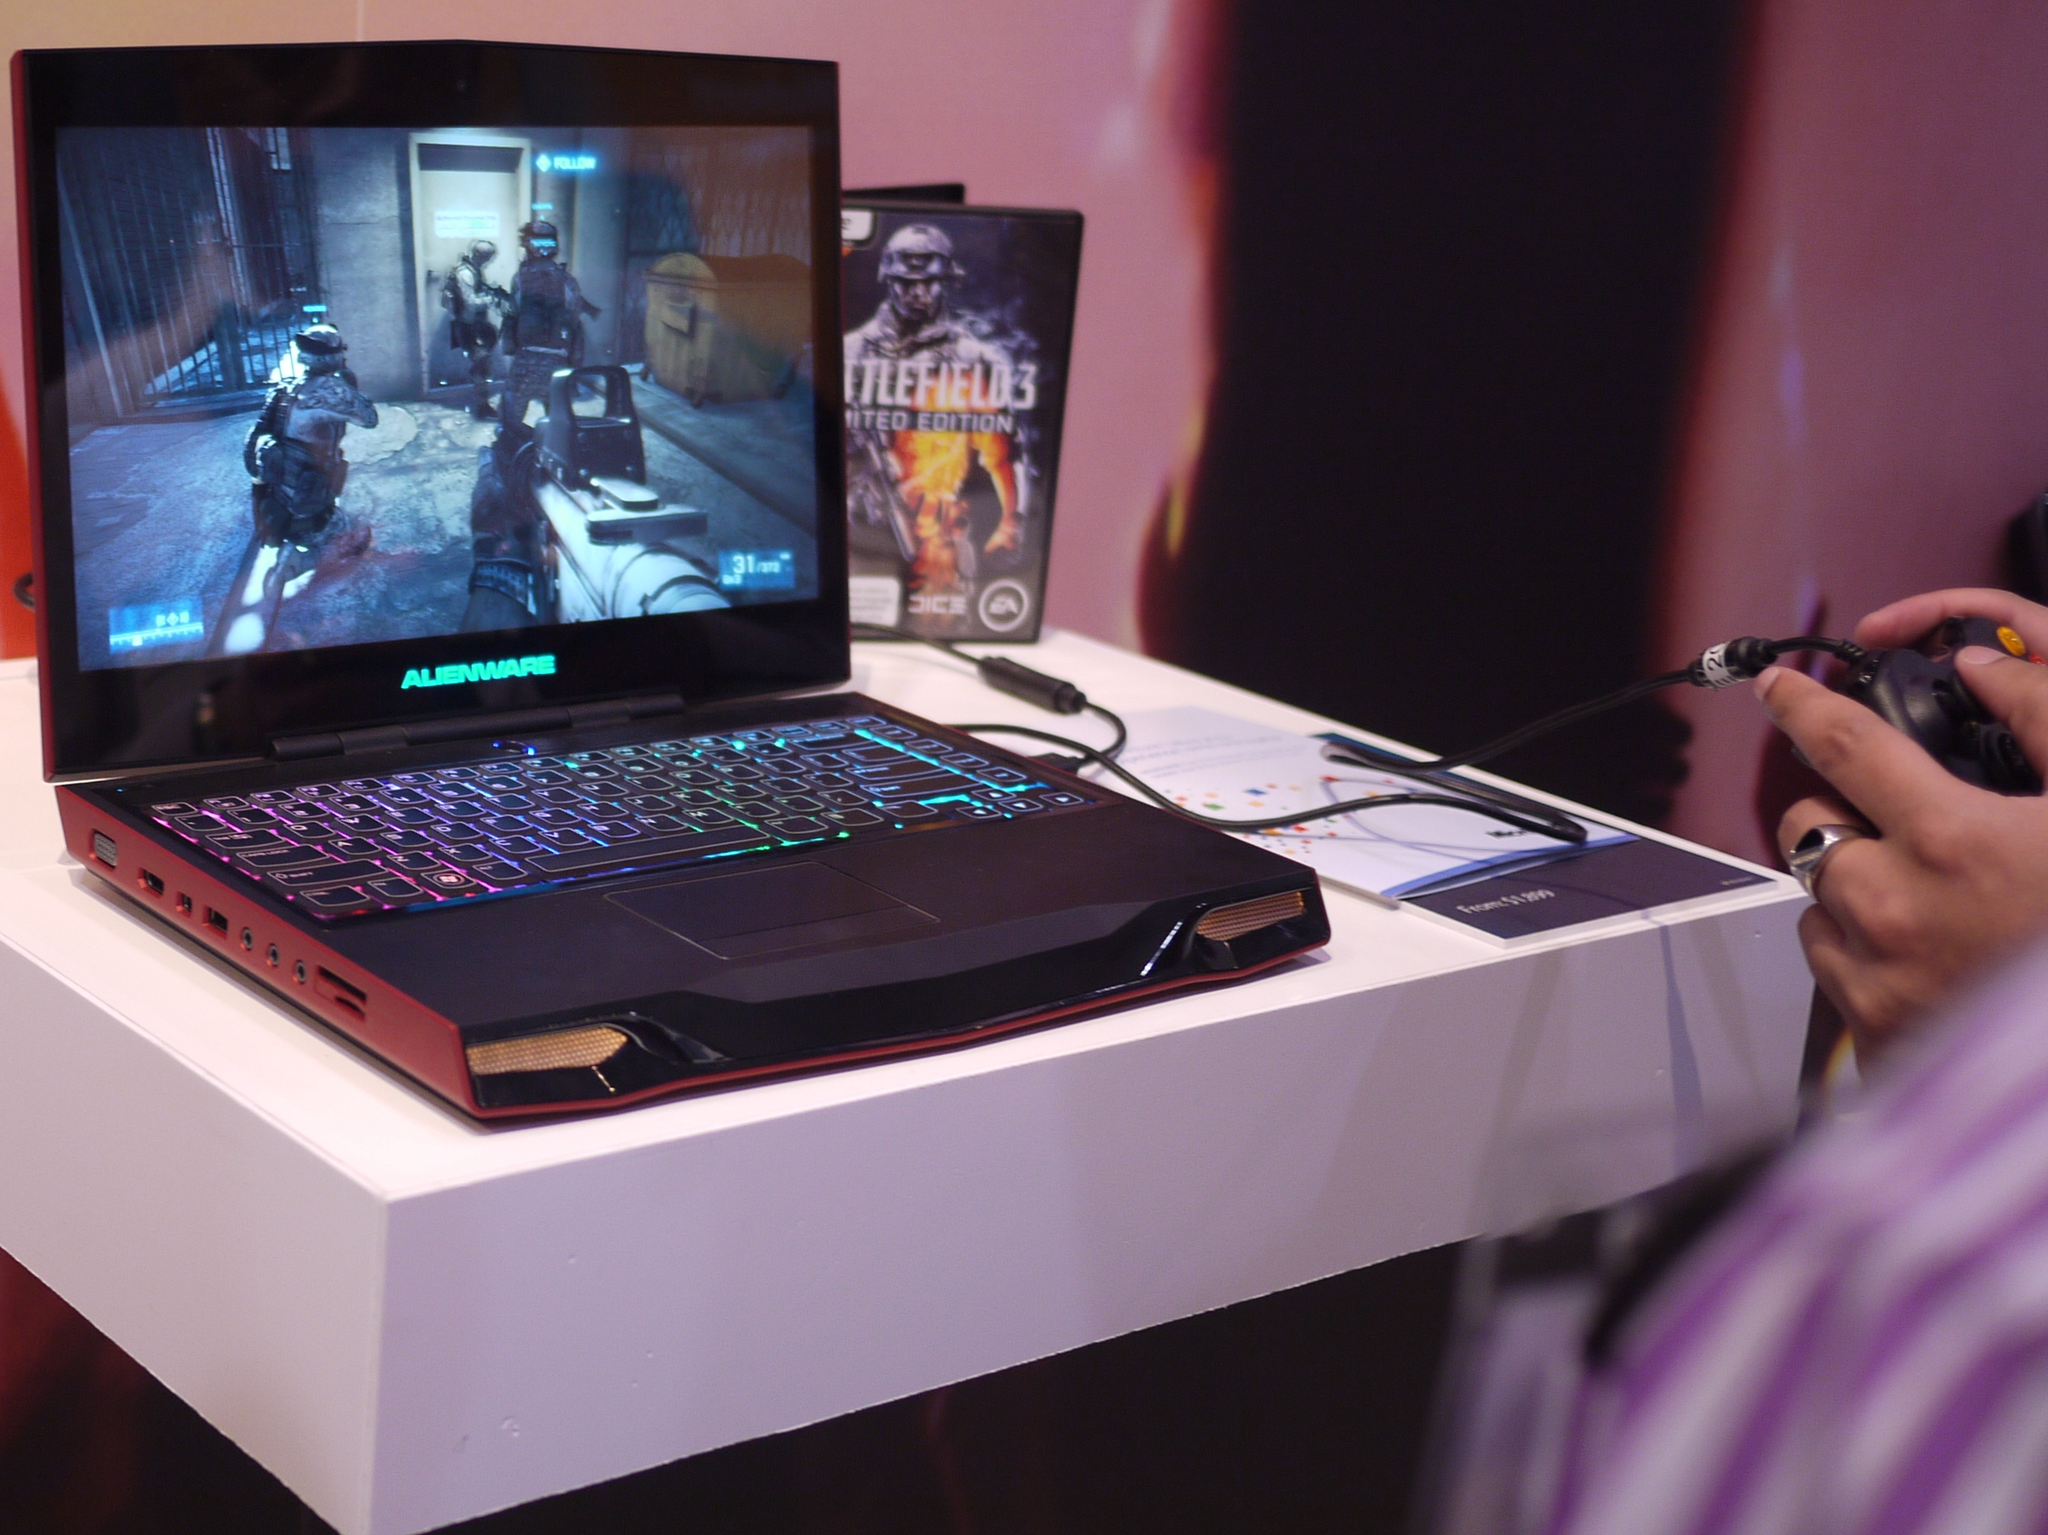<image>
Share a concise interpretation of the image provided. Someone playing a video game on an Alienware laptop. 